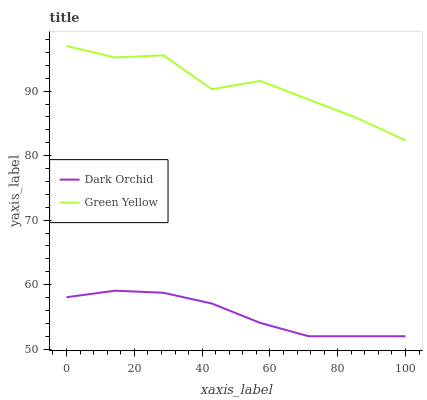Does Dark Orchid have the minimum area under the curve?
Answer yes or no. Yes. Does Green Yellow have the maximum area under the curve?
Answer yes or no. Yes. Does Dark Orchid have the maximum area under the curve?
Answer yes or no. No. Is Dark Orchid the smoothest?
Answer yes or no. Yes. Is Green Yellow the roughest?
Answer yes or no. Yes. Is Dark Orchid the roughest?
Answer yes or no. No. Does Dark Orchid have the lowest value?
Answer yes or no. Yes. Does Green Yellow have the highest value?
Answer yes or no. Yes. Does Dark Orchid have the highest value?
Answer yes or no. No. Is Dark Orchid less than Green Yellow?
Answer yes or no. Yes. Is Green Yellow greater than Dark Orchid?
Answer yes or no. Yes. Does Dark Orchid intersect Green Yellow?
Answer yes or no. No. 